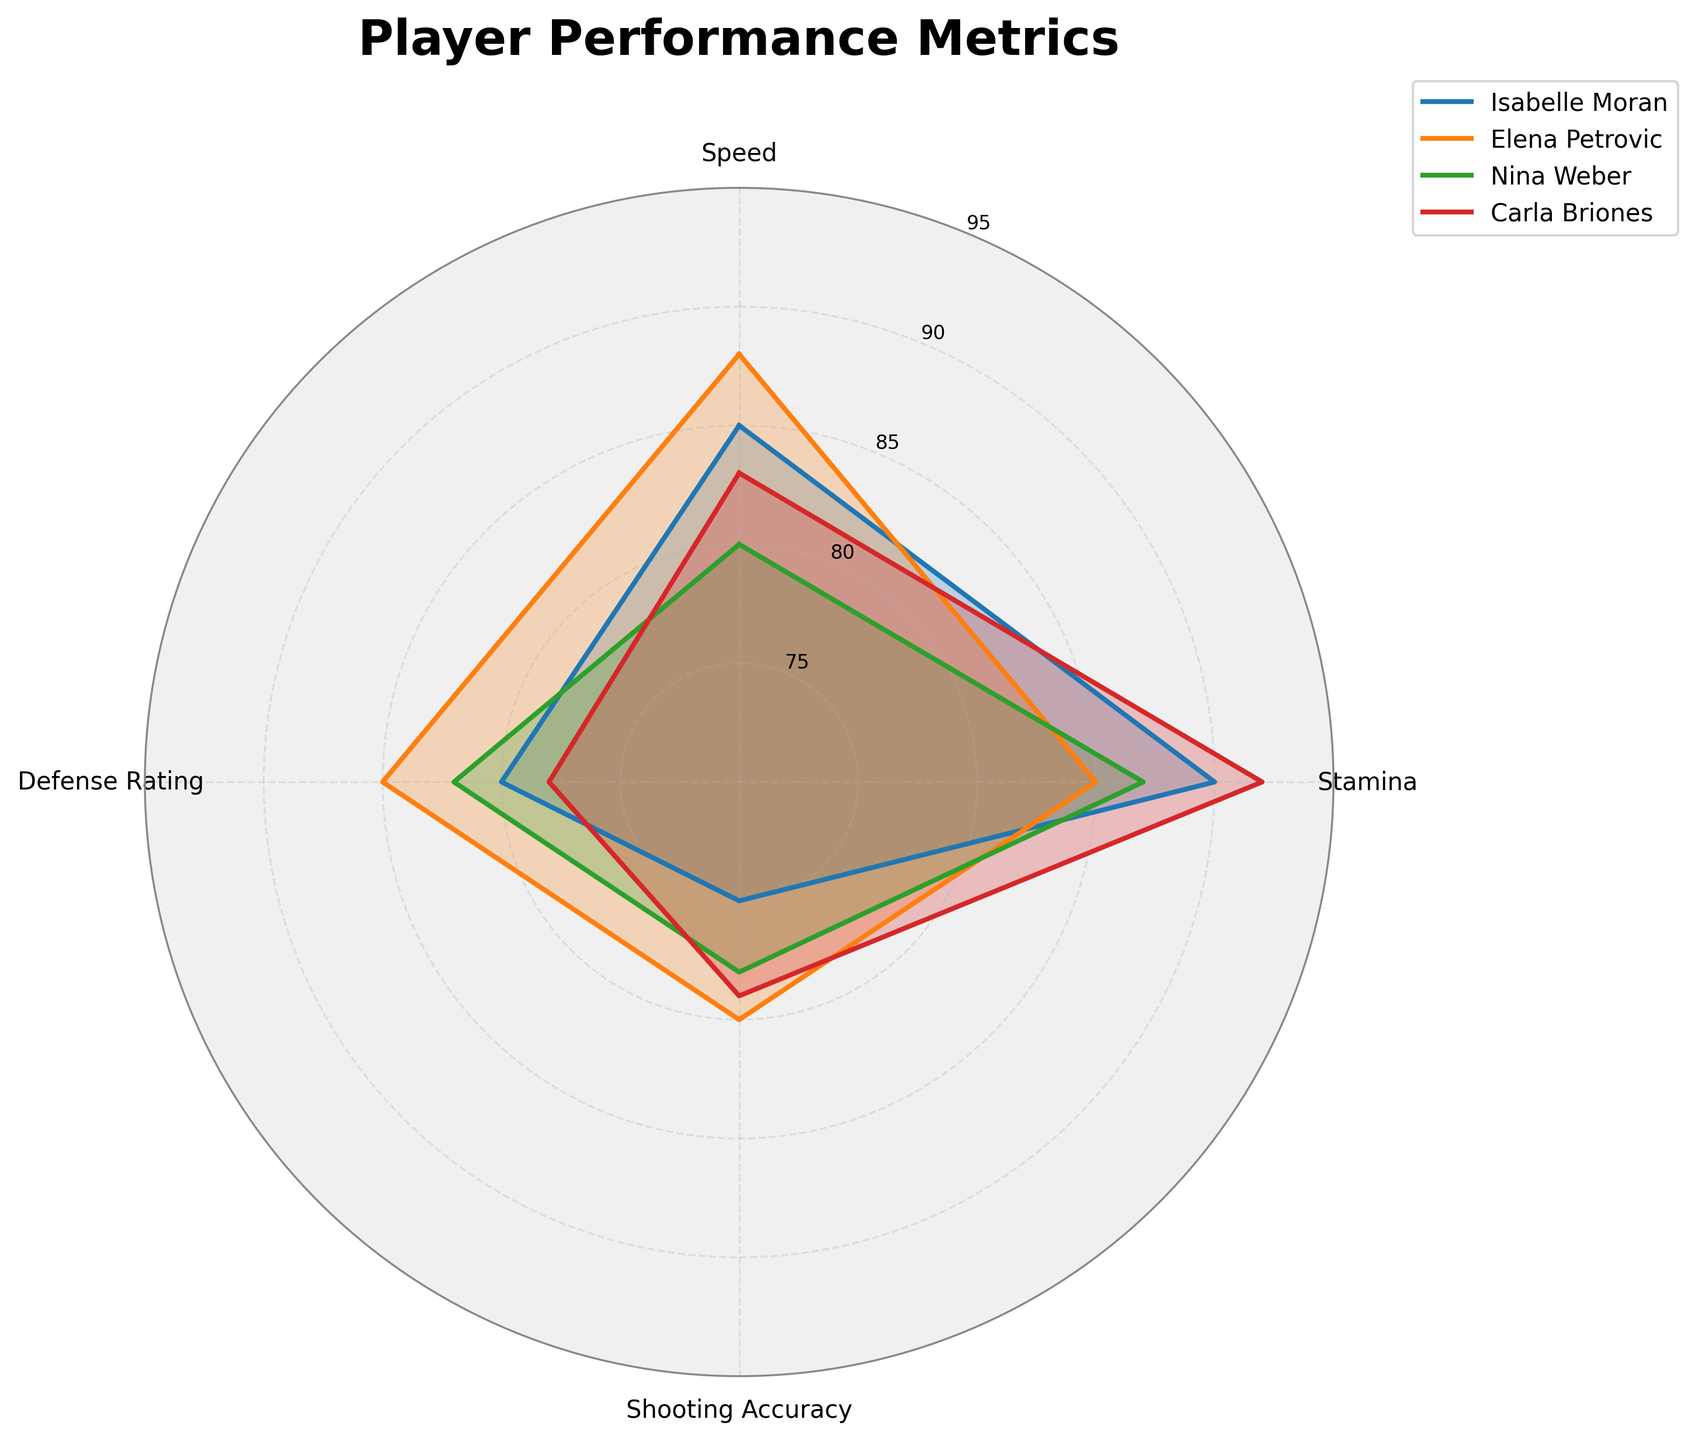What's the title of the figure? The title of the figure is found at the top-center, usually displayed in bold and larger font size compared to other text. In this case, it's "Player Performance Metrics".
Answer: Player Performance Metrics How many players' data are compared in the radar chart? The radar chart has four distinct lines or shaded areas, each corresponding to a player. The legend on the right side lists the names of Isabelle Moran, Elena Petrovic, Nina Weber, and Carla Briones.
Answer: Four Which player has the highest Stamina rating? The Stamina rating can be identified on the radar chart's specific axis. The player whose line reaches the furthest toward the outer ring on the Stamina axis has the highest rating. Carla Briones has the maximum value at 92.
Answer: Carla Briones Who has the lowest Defense Rating and how much is it? By examining the Defense Rating axis, the smallest value can be identified by finding the line or shaded area that reaches the least distance from the center. Carla Briones has the lowest Defense Rating at 78.
Answer: Carla Briones with 78 Which player shows the most balanced performance across all metrics? A balanced performance would reflect in more uniform distances from the center across all axes in the radar chart. Elena Petrovic's values are quite consistent across all metrics (Speed: 88, Stamina: 85, Shooting Accuracy: 80, Defense Rating: 85), showing a balanced performance.
Answer: Elena Petrovic What is the average Shooting Accuracy of all the players? To find the average Shooting Accuracy, sum all players' shooting accuracy values (75 + 80 + 78 + 79) and divide by the number of players, which is 4. (75 + 80 + 78 + 79) / 4 = 78.
Answer: 78 Compare the Speed ratings of Isabelle Moran and Nina Weber. The Speed ratings can be directly compared by inspecting the respective points on the Speed axis of the radar chart. Isabelle Moran has a Speed rating of 85, while Nina Weber has a rating of 80. Isabelle's rating is higher by 5 points.
Answer: Isabelle Moran has a higher Speed rating by 5 points Which metric shows the largest variation among all players? The metric with the largest variation would have the widest range of values among the players. Checking Speed (85-80=5), Stamina (92-85=7), Shooting Accuracy (80-75=5), and Defense Rating (85-78=7), both Stamina and Defense Rating show a variation of 7.
Answer: Stamina and Defense Rating Which two players have the closest total score (sum of all metrics)? Calculate the total score for each player: Isabelle Moran (85+90+75+80=330), Elena Petrovic (88+85+80+85=338), Nina Weber (80+87+78+82=327), Carla Briones (83+92+79+78=332). Compare the sums, and players with the closest scores are Carla Briones (332) and Isabelle Moran (330).
Answer: Carla Briones and Isabelle Moran Which player excels the most in Shooting Accuracy, and by how much compared to the next best? Identify the maximum Shooting Accuracy and the second highest. Elena Petrovic has the highest at 80, followed by Carla Briones at 79. The difference is 80 - 79 = 1.
Answer: Elena Petrovic by 1 